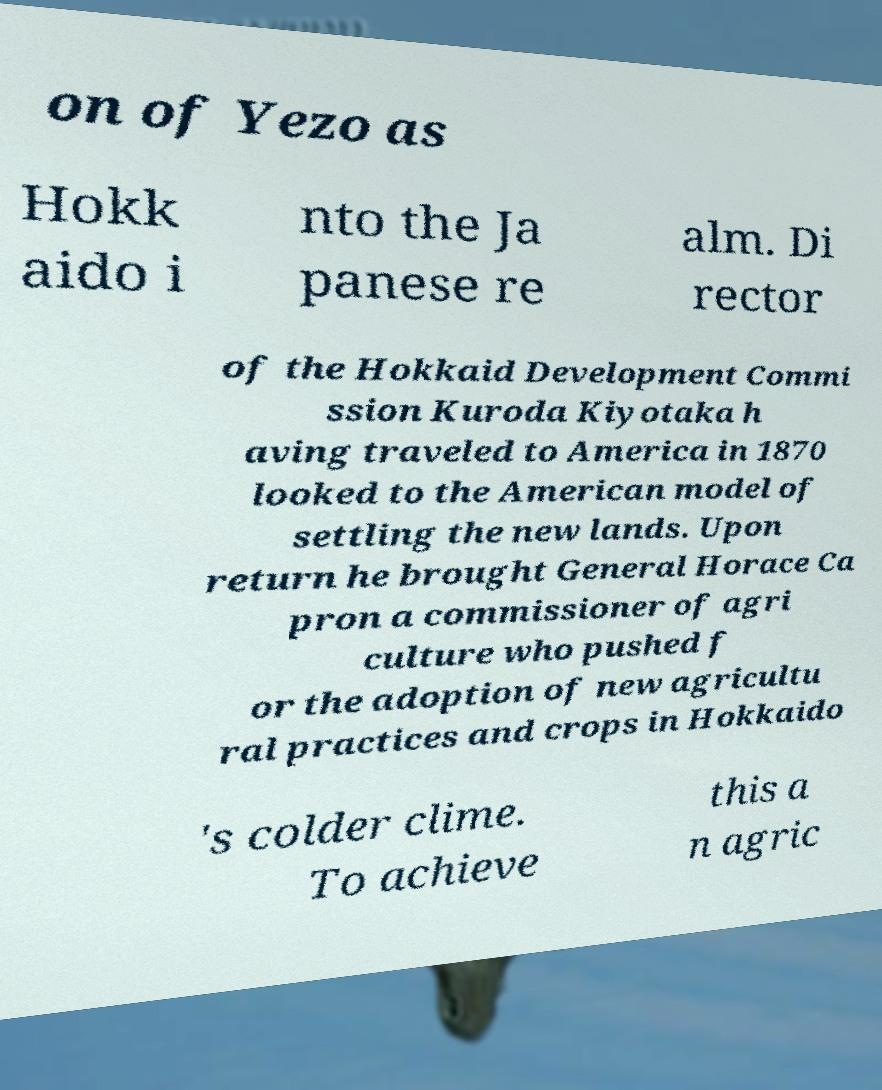Can you read and provide the text displayed in the image?This photo seems to have some interesting text. Can you extract and type it out for me? on of Yezo as Hokk aido i nto the Ja panese re alm. Di rector of the Hokkaid Development Commi ssion Kuroda Kiyotaka h aving traveled to America in 1870 looked to the American model of settling the new lands. Upon return he brought General Horace Ca pron a commissioner of agri culture who pushed f or the adoption of new agricultu ral practices and crops in Hokkaido 's colder clime. To achieve this a n agric 